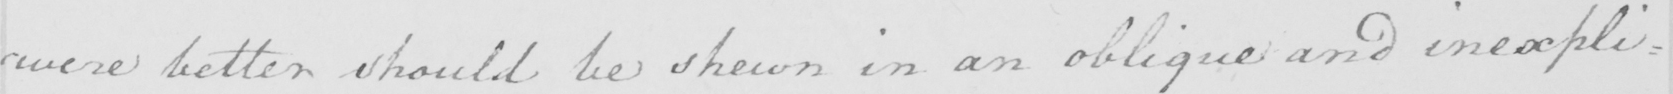Can you read and transcribe this handwriting? were better should be shewn in an oblique and inexpli : 